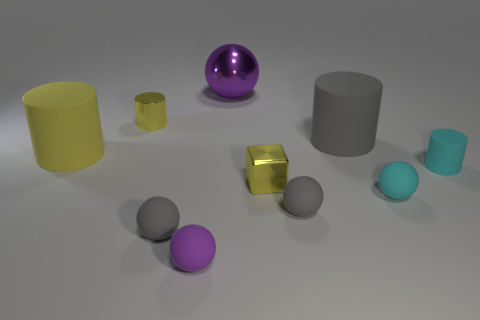Subtract all large balls. How many balls are left? 4 Subtract 1 blocks. How many blocks are left? 0 Subtract all yellow cylinders. How many cylinders are left? 2 Subtract all cubes. How many objects are left? 9 Subtract all blue cylinders. Subtract all green spheres. How many cylinders are left? 4 Subtract all yellow blocks. How many red cylinders are left? 0 Subtract all gray matte spheres. Subtract all large gray matte cylinders. How many objects are left? 7 Add 8 big yellow cylinders. How many big yellow cylinders are left? 9 Add 4 gray matte things. How many gray matte things exist? 7 Subtract 1 gray cylinders. How many objects are left? 9 